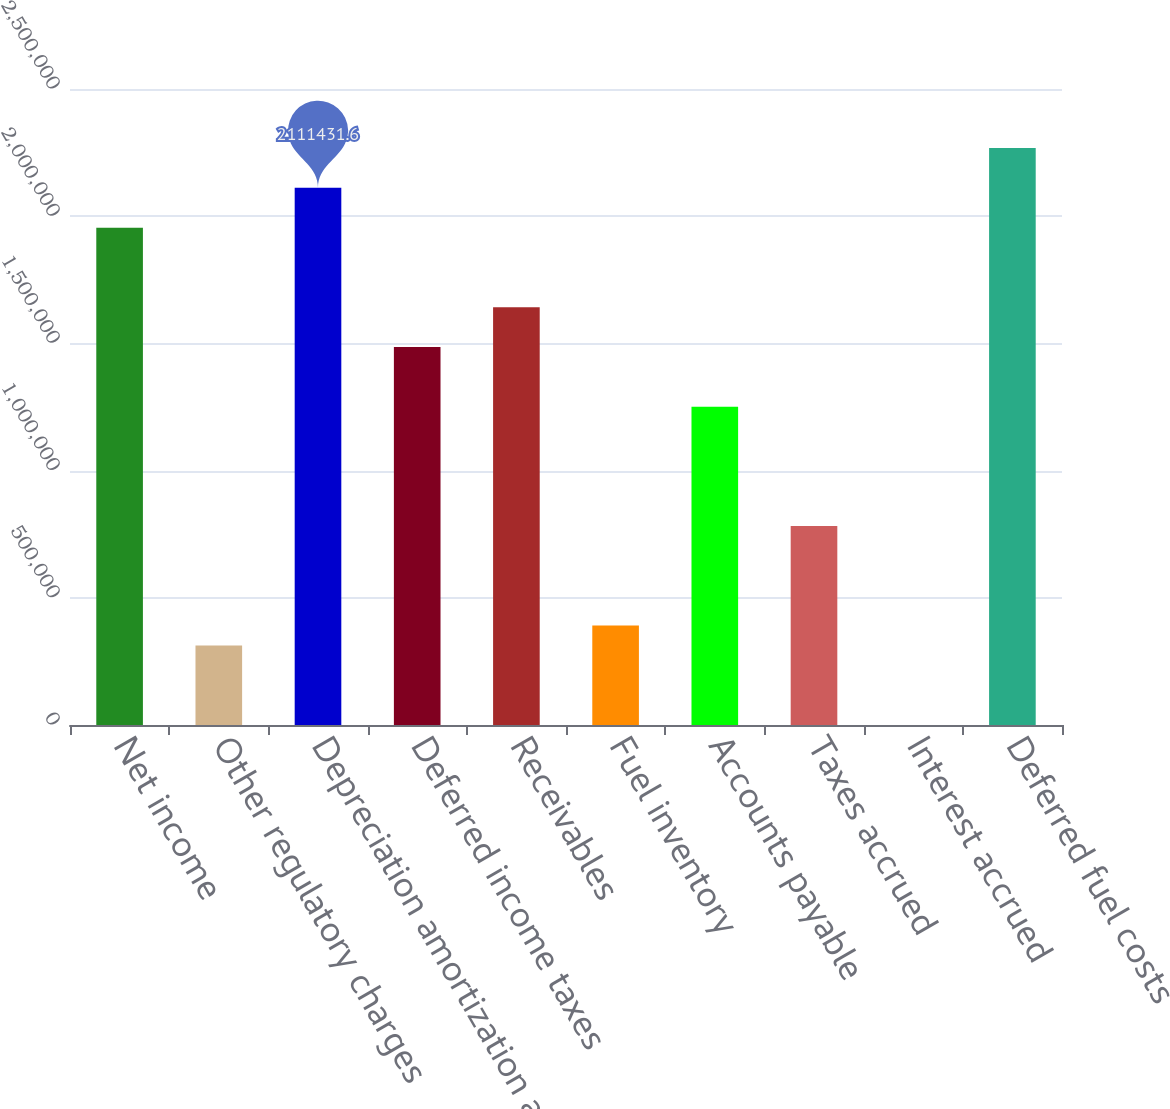Convert chart. <chart><loc_0><loc_0><loc_500><loc_500><bar_chart><fcel>Net income<fcel>Other regulatory charges<fcel>Depreciation amortization and<fcel>Deferred income taxes<fcel>Receivables<fcel>Fuel inventory<fcel>Accounts payable<fcel>Taxes accrued<fcel>Interest accrued<fcel>Deferred fuel costs<nl><fcel>1.95504e+06<fcel>312928<fcel>2.11143e+06<fcel>1.48587e+06<fcel>1.64226e+06<fcel>391124<fcel>1.25128e+06<fcel>782103<fcel>145<fcel>2.26782e+06<nl></chart> 